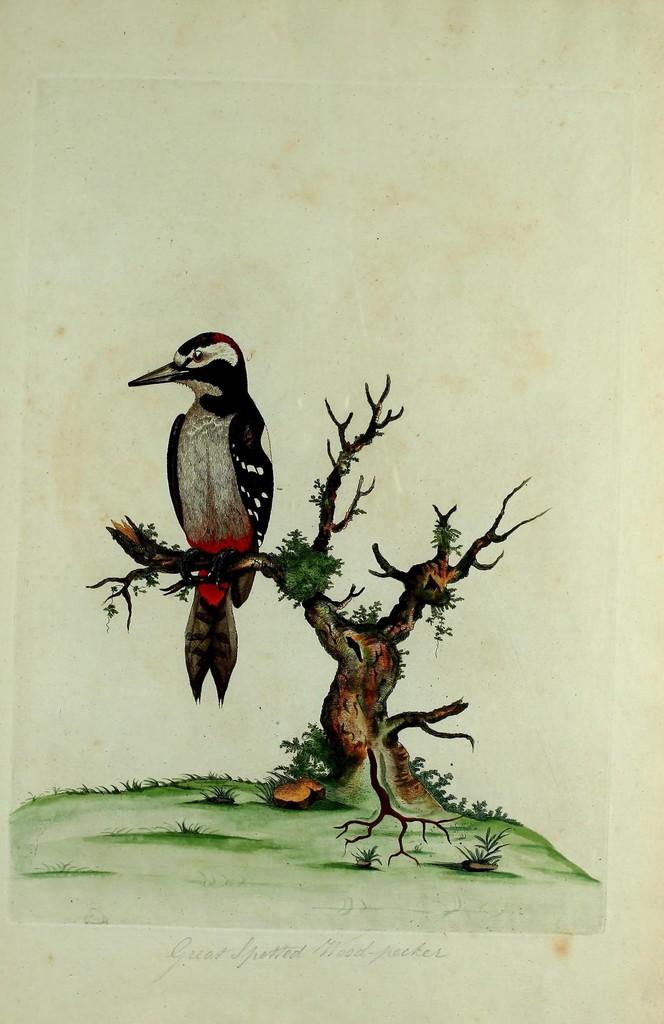What is the main subject of the image? There is a painting in the image. What is depicted in the painting? The painting depicts a bird. Where is the bird located in the painting? The bird is on the branch of a tree in the painting. What type of joke is the bird telling in the painting? There is no joke being told by the bird in the painting; it is simply depicted on the branch of a tree. 